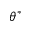<formula> <loc_0><loc_0><loc_500><loc_500>\theta ^ { * }</formula> 